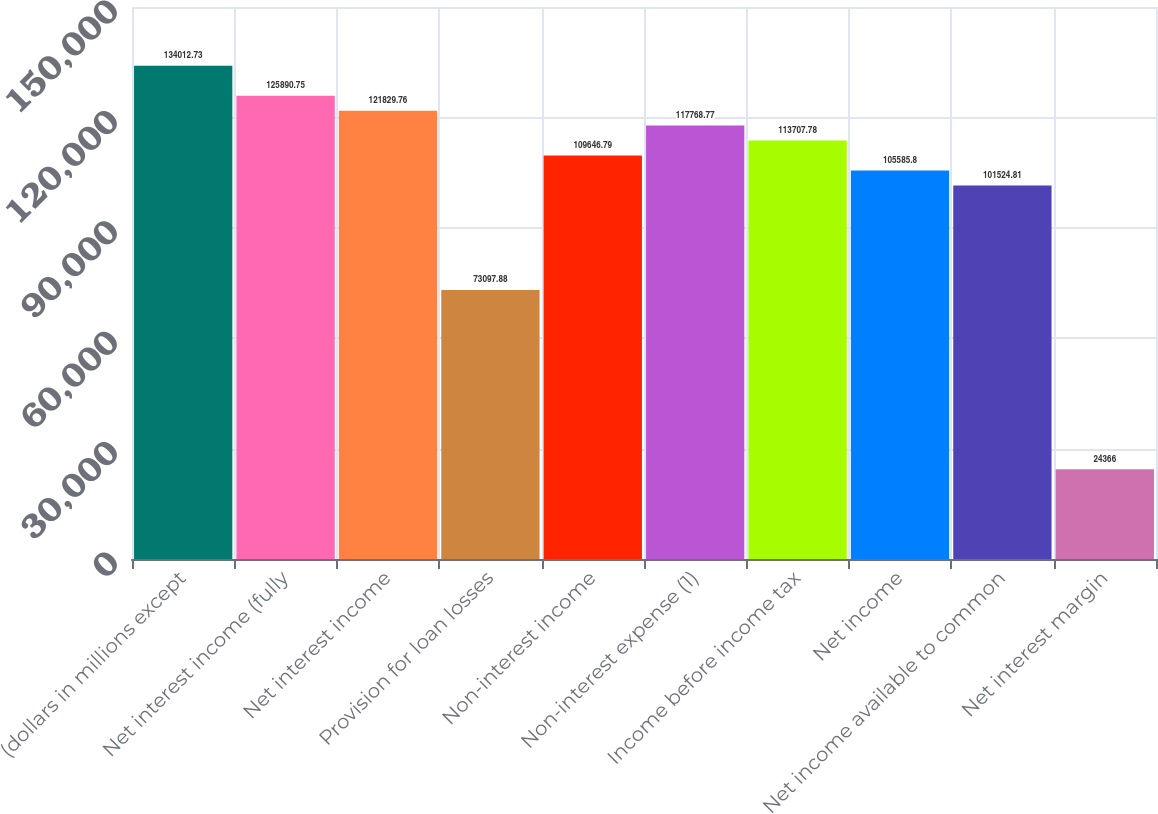<chart> <loc_0><loc_0><loc_500><loc_500><bar_chart><fcel>(dollars in millions except<fcel>Net interest income (fully<fcel>Net interest income<fcel>Provision for loan losses<fcel>Non-interest income<fcel>Non-interest expense (1)<fcel>Income before income tax<fcel>Net income<fcel>Net income available to common<fcel>Net interest margin<nl><fcel>134013<fcel>125891<fcel>121830<fcel>73097.9<fcel>109647<fcel>117769<fcel>113708<fcel>105586<fcel>101525<fcel>24366<nl></chart> 